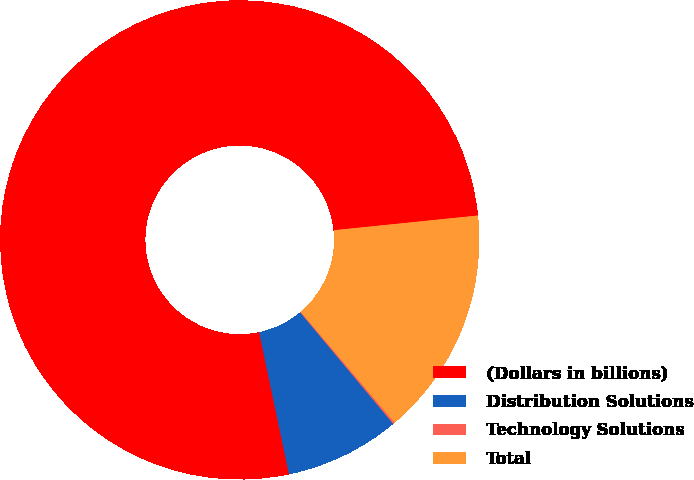<chart> <loc_0><loc_0><loc_500><loc_500><pie_chart><fcel>(Dollars in billions)<fcel>Distribution Solutions<fcel>Technology Solutions<fcel>Total<nl><fcel>76.68%<fcel>7.77%<fcel>0.12%<fcel>15.43%<nl></chart> 